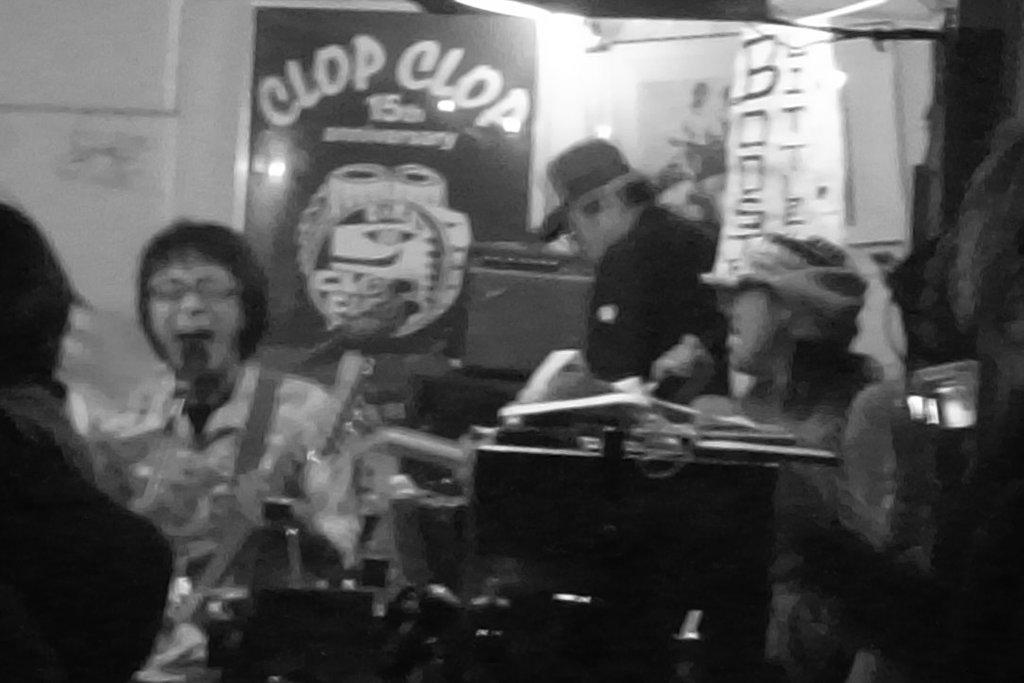What is the color scheme of the image? The image is black and white. How would you describe the clarity of the image? The image is slightly blurred. What can be seen in the image in terms of human presence? There are people sitting in the image. What is one of the prominent objects in the image? There is a board in the image. What else can be seen hanging in the image? There is a banner in the image. Can you describe any other objects present in the image? Yes, there are objects present in the image. How does the camera blow air onto the people in the image? There is no camera present in the image, and therefore it cannot blow air onto the people. 